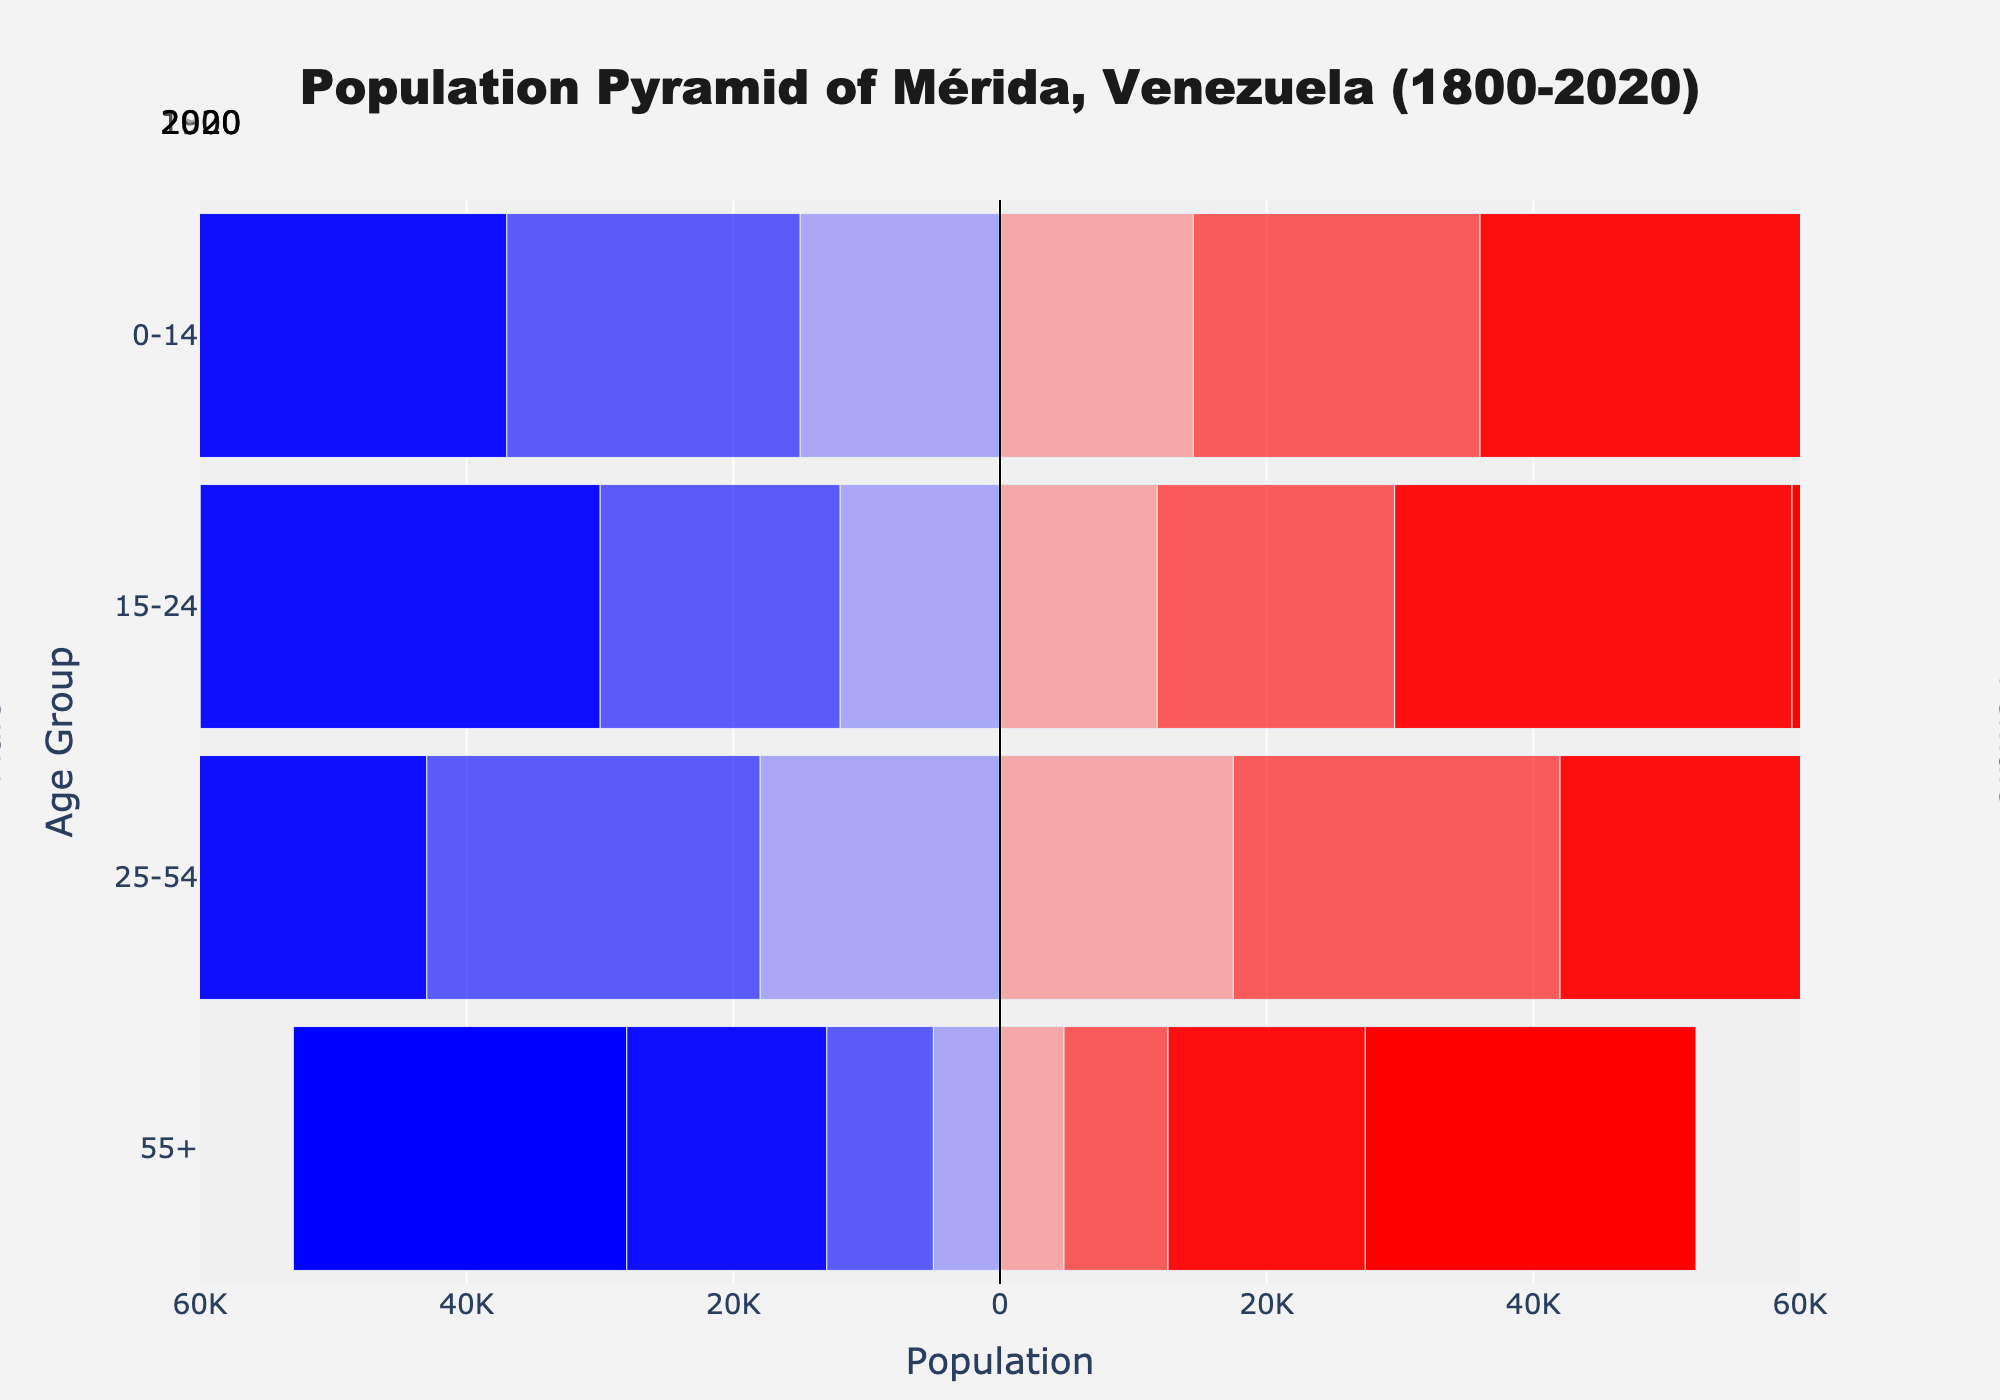What time period does the title of the population pyramid cover? The title of the figure states "Population Pyramid of Mérida, Venezuela (1800-2020)," which indicates the time range covered is from the year 1800 to 2020.
Answer: 1800-2020 Which age group had the highest female population in 2020? In 2020, the female population is highest in the "25-54" age group as indicated by the longest bar towards the right side in the 2020 section of the pyramid.
Answer: 25-54 What is the total population for the age group 15-24 in 1800? To find the total population for the age group 15-24 in 1800, sum the male and female populations: 12,000 (males) + 11,800 (females) = 23,800.
Answer: 23,800 By how much did the population of the age group 55+ increase from 1800 to 2020? To find the increase, calculate the difference between the populations in 2020 and 1800. For males: 25,000 (2020) - 5,000 (1800) = 20,000. For females: 24,800 (2020) - 4,800 (1800) = 20,000. The increase is 20,000 for both genders combined.
Answer: 20,000 each Which year shows the widest disparity between the male and female population in the 0-14 age group, and what is the disparity? For the 0-14 age group, check the difference for each year. In 1800, the disparity is 500 (15,000 males - 14,500 females). In 1900, it is 500 (22,000 males - 21,500 females). In 2000, it is 500 (35,000 males - 34,500 females). In 2020, it is 500 (40,000 males - 39,500 females). Thus, the widest disparity occurs in all given years.
Answer: 500 in all years Which age group saw the highest increase in total population between 1900 and 2000? Calculate the total population increase for each age group between 1900 and 2000. For 0-14: (35,000+34,500) - (22,000+21,500) = 26,000. For 15-24: (30,000+29,800) - (18,000+17,800) = 24,000. For 25-54: (45,000+44,500) - (25,000+24,500) = 40,000. For 55+: (15,000+14,800) - (8,000+7,800) = 13,200. The highest increase is in the 25-54 age group.
Answer: 25-54 What is the trend for the 0-14 age group from 1800 to 2020? The population for the 0-14 age group consistently increases over each recorded year: 1800 (29,500), 1900 (43,500), 2000 (69,500), 2020 (79,500).
Answer: Increasing Which gender, across all years, generally had a higher population in the 25-54 age group? In all years (1800, 1900, 2000, 2020), the female population is slightly lower in each instance for the 25-54 age group, indicating males generally had a higher population in this group.
Answer: Males 